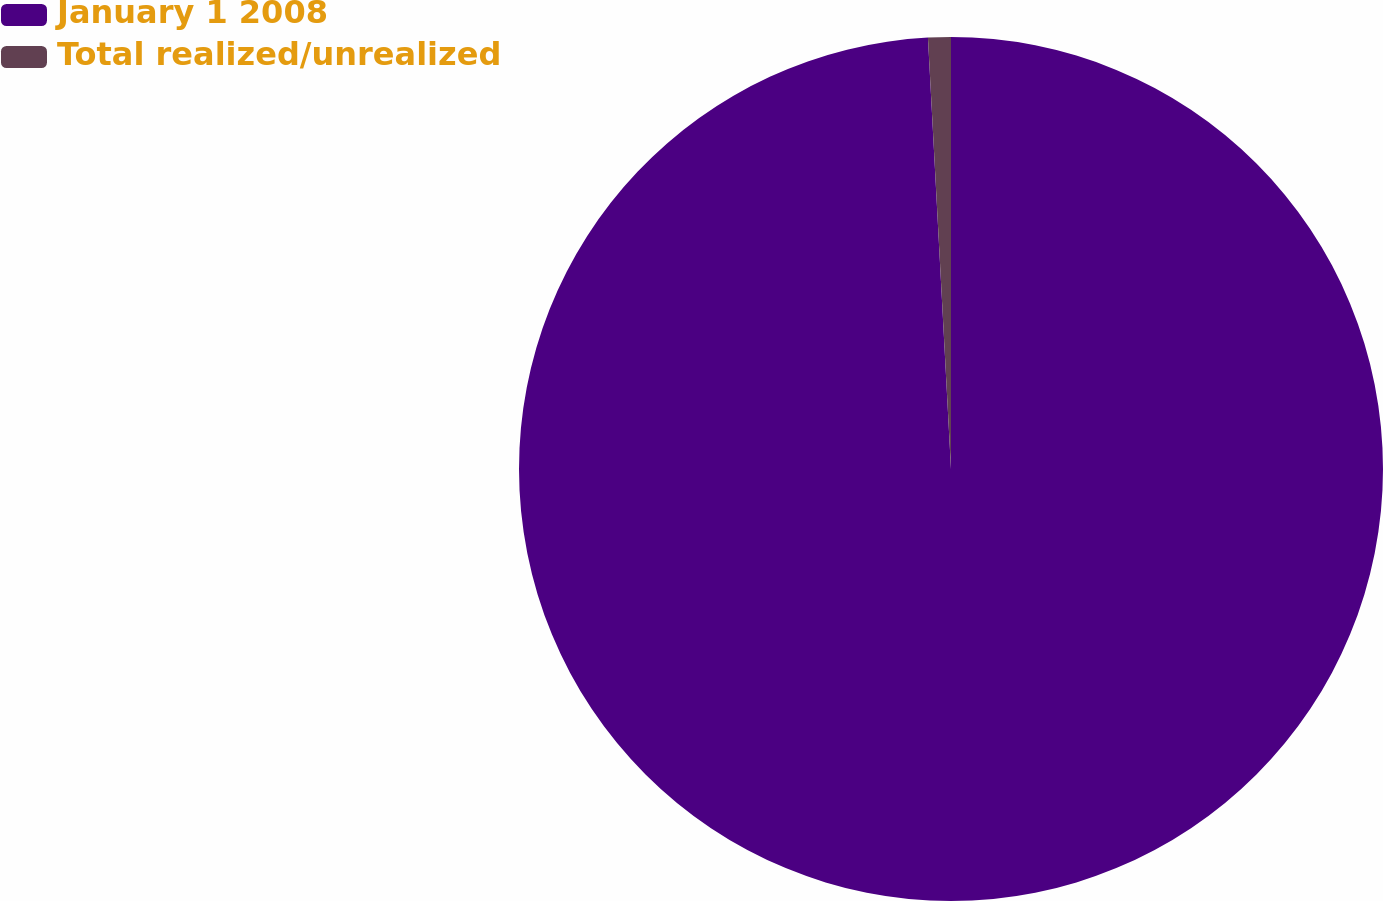Convert chart to OTSL. <chart><loc_0><loc_0><loc_500><loc_500><pie_chart><fcel>January 1 2008<fcel>Total realized/unrealized<nl><fcel>99.15%<fcel>0.85%<nl></chart> 